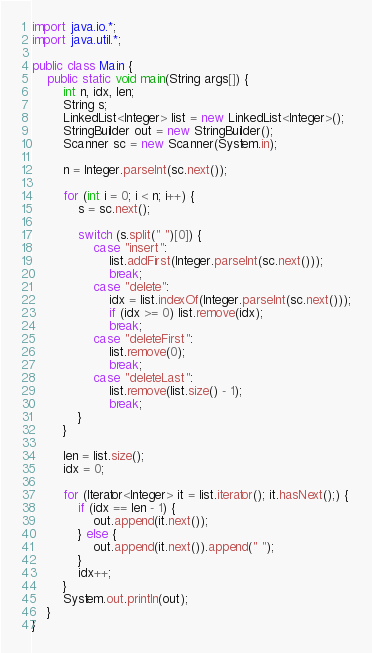<code> <loc_0><loc_0><loc_500><loc_500><_Java_>import java.io.*;
import java.util.*;

public class Main {
    public static void main(String args[]) {
        int n, idx, len;
        String s;
        LinkedList<Integer> list = new LinkedList<Integer>();
        StringBuilder out = new StringBuilder();
        Scanner sc = new Scanner(System.in);

        n = Integer.parseInt(sc.next());

        for (int i = 0; i < n; i++) {
            s = sc.next();

            switch (s.split(" ")[0]) {
                case "insert":
                    list.addFirst(Integer.parseInt(sc.next()));
                    break;
                case "delete":
                    idx = list.indexOf(Integer.parseInt(sc.next()));
                    if (idx >= 0) list.remove(idx);
                    break;
                case "deleteFirst":
                    list.remove(0);
                    break;
                case "deleteLast":
                    list.remove(list.size() - 1);
                    break;
            }
        }

        len = list.size();
        idx = 0;

        for (Iterator<Integer> it = list.iterator(); it.hasNext();) {
            if (idx == len - 1) {
                out.append(it.next());
            } else {
                out.append(it.next()).append(" ");
            }
            idx++;
        }
        System.out.println(out);
    }
}</code> 